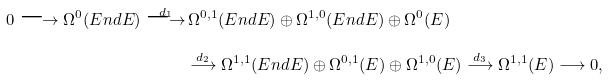Convert formula to latex. <formula><loc_0><loc_0><loc_500><loc_500>0 \longrightarrow \Omega ^ { 0 } ( E n d E ) \overset { d _ { 1 } } \longrightarrow & \, \Omega ^ { 0 , 1 } ( E n d E ) \oplus \Omega ^ { 1 , 0 } ( E n d E ) \oplus \Omega ^ { 0 } ( E ) \\ & \overset { d _ { 2 } } \longrightarrow \Omega ^ { 1 , 1 } ( E n d E ) \oplus \Omega ^ { 0 , 1 } ( E ) \oplus \Omega ^ { 1 , 0 } ( E ) \overset { d _ { 3 } } \longrightarrow \Omega ^ { 1 , 1 } ( E ) \longrightarrow 0 ,</formula> 